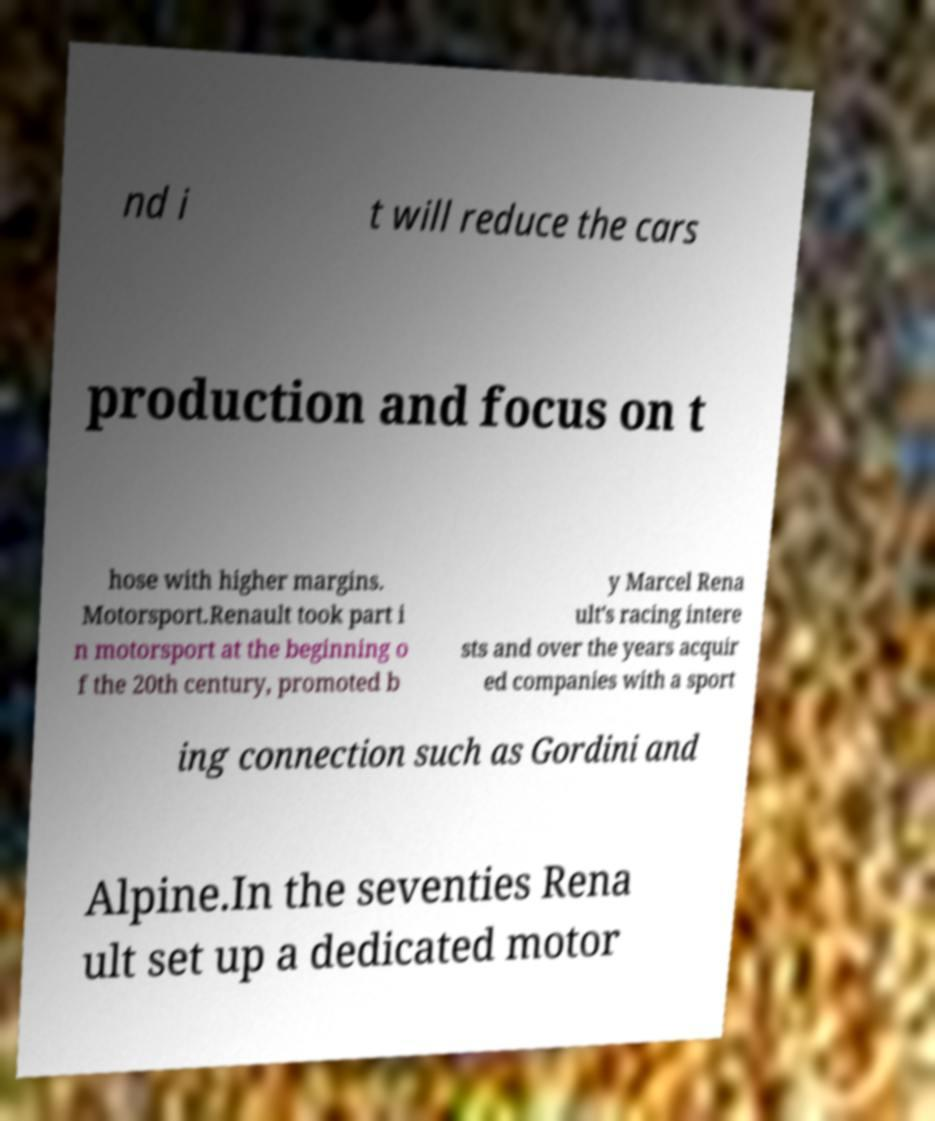Please identify and transcribe the text found in this image. nd i t will reduce the cars production and focus on t hose with higher margins. Motorsport.Renault took part i n motorsport at the beginning o f the 20th century, promoted b y Marcel Rena ult's racing intere sts and over the years acquir ed companies with a sport ing connection such as Gordini and Alpine.In the seventies Rena ult set up a dedicated motor 